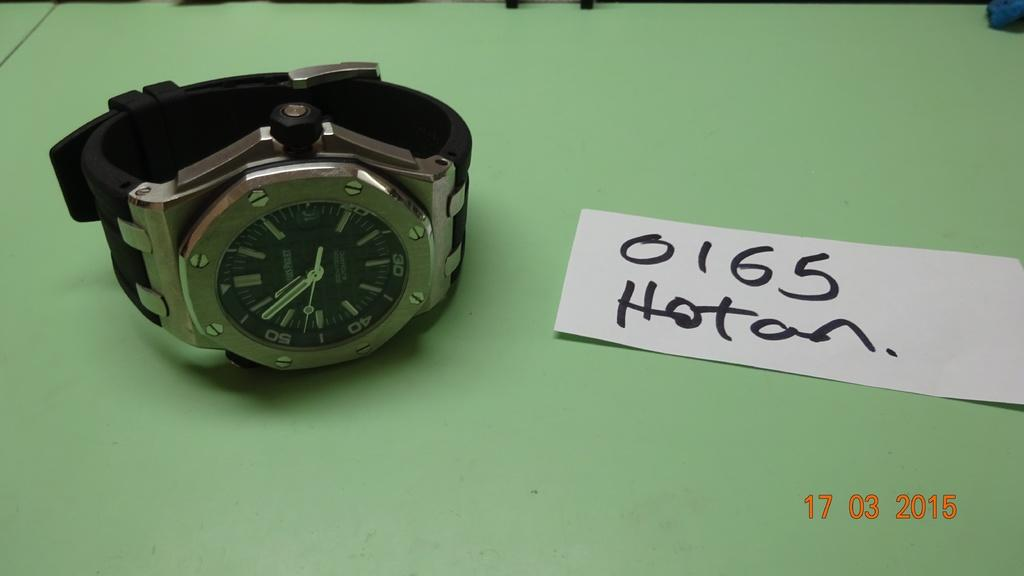<image>
Give a short and clear explanation of the subsequent image. The date stamp on the photo of a watch is 17/03/2015 